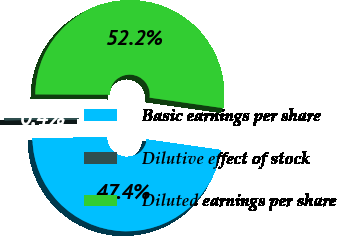<chart> <loc_0><loc_0><loc_500><loc_500><pie_chart><fcel>Basic earnings per share<fcel>Dilutive effect of stock<fcel>Diluted earnings per share<nl><fcel>47.43%<fcel>0.39%<fcel>52.18%<nl></chart> 